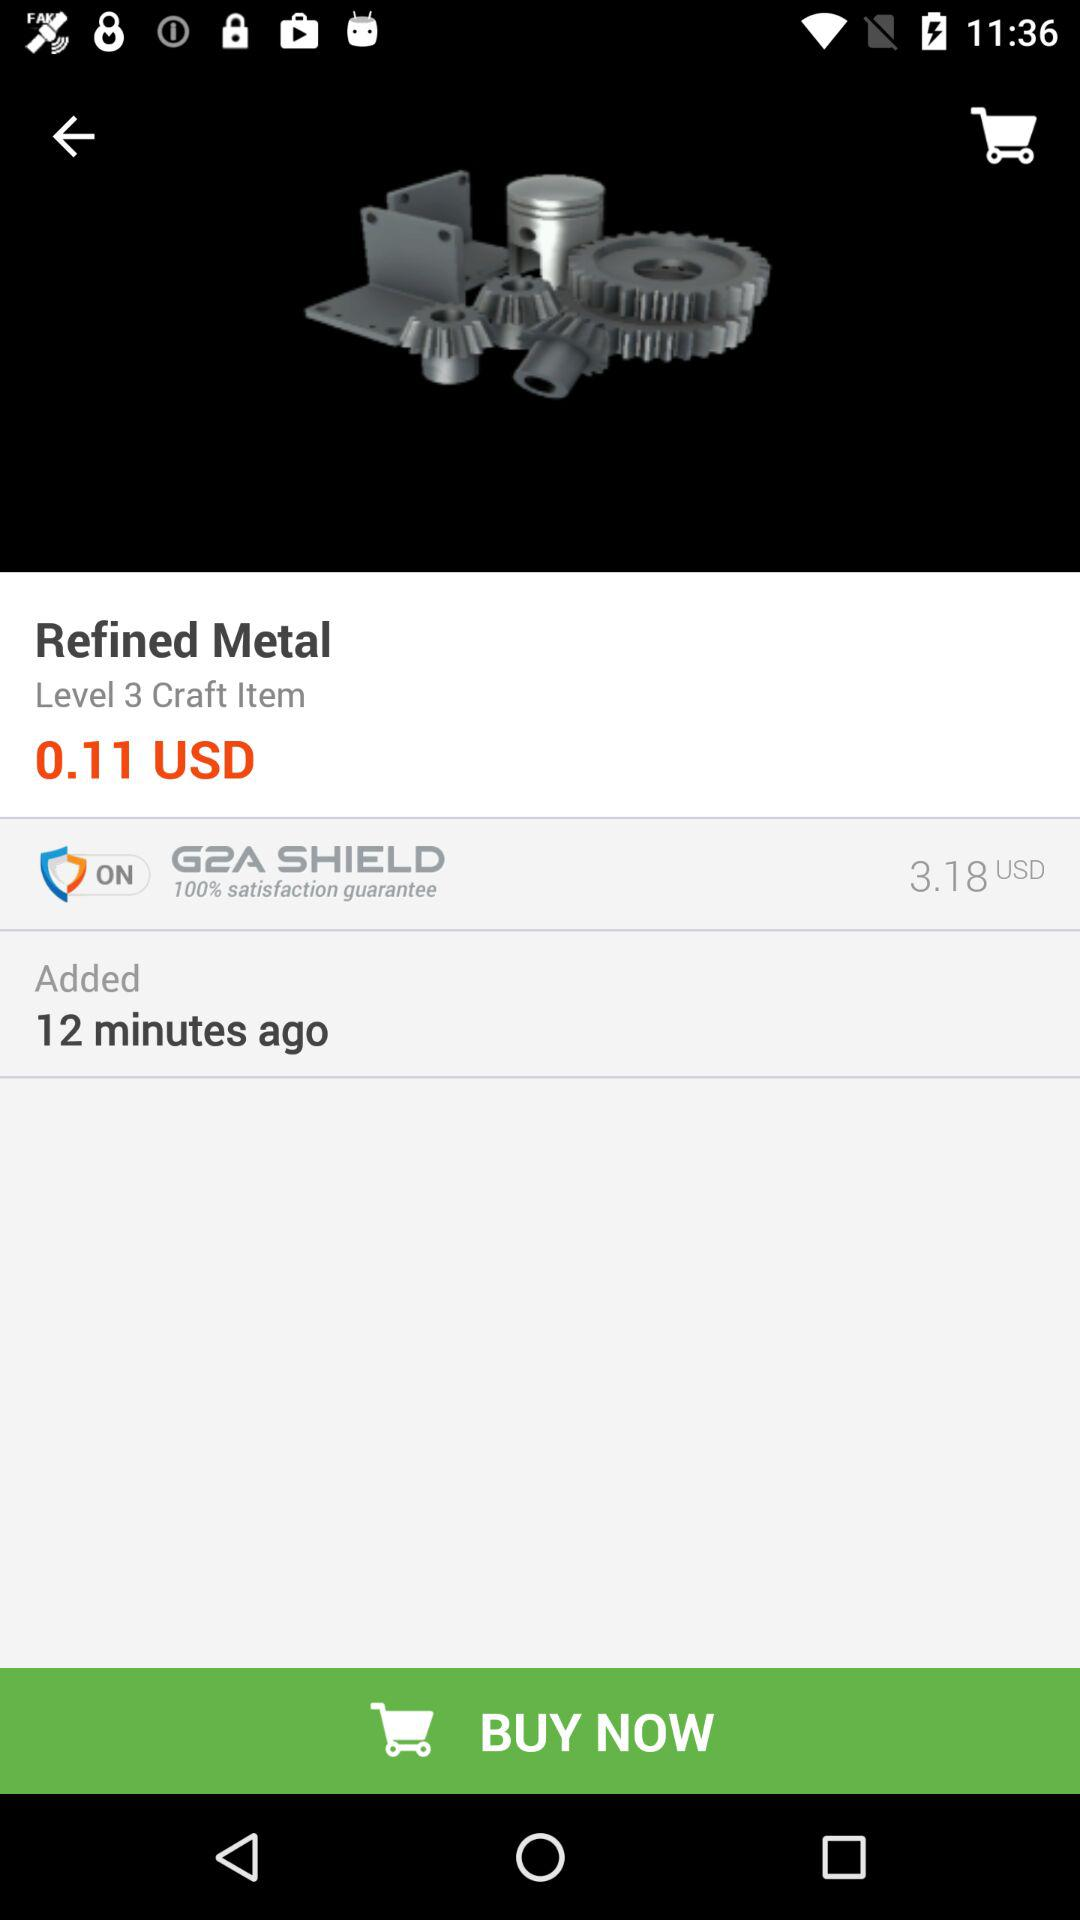What is the name of the metal? The name of the metal is "Refined Metal". 